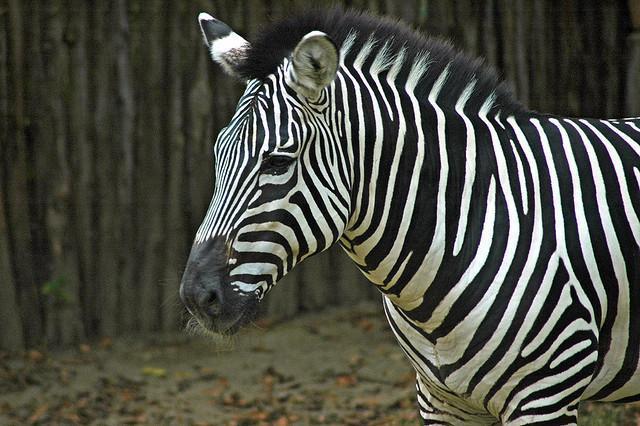How many zebra are there?
Give a very brief answer. 1. How many people are wearing blue shirts?
Give a very brief answer. 0. 